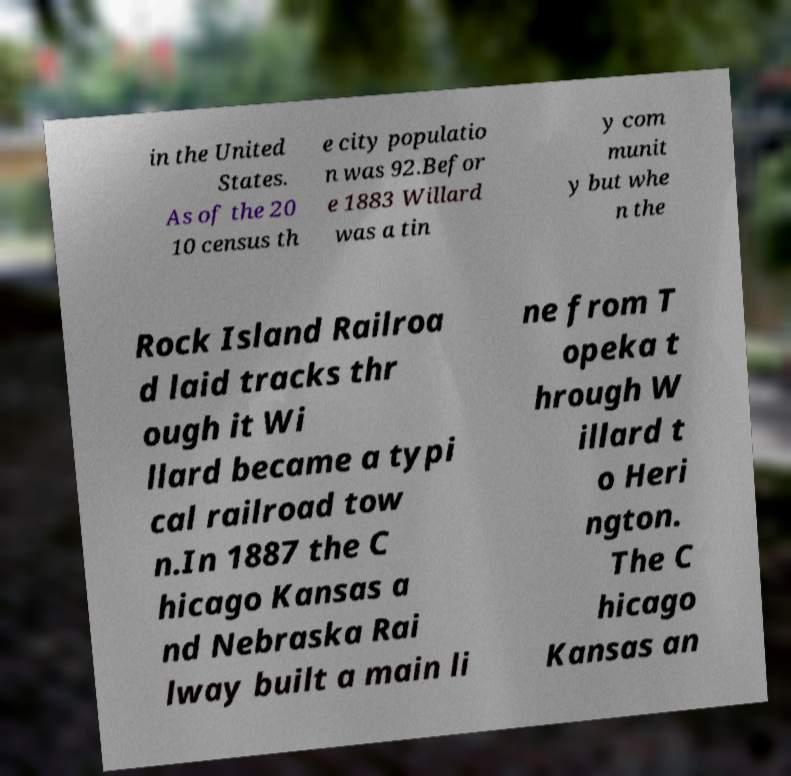What messages or text are displayed in this image? I need them in a readable, typed format. in the United States. As of the 20 10 census th e city populatio n was 92.Befor e 1883 Willard was a tin y com munit y but whe n the Rock Island Railroa d laid tracks thr ough it Wi llard became a typi cal railroad tow n.In 1887 the C hicago Kansas a nd Nebraska Rai lway built a main li ne from T opeka t hrough W illard t o Heri ngton. The C hicago Kansas an 